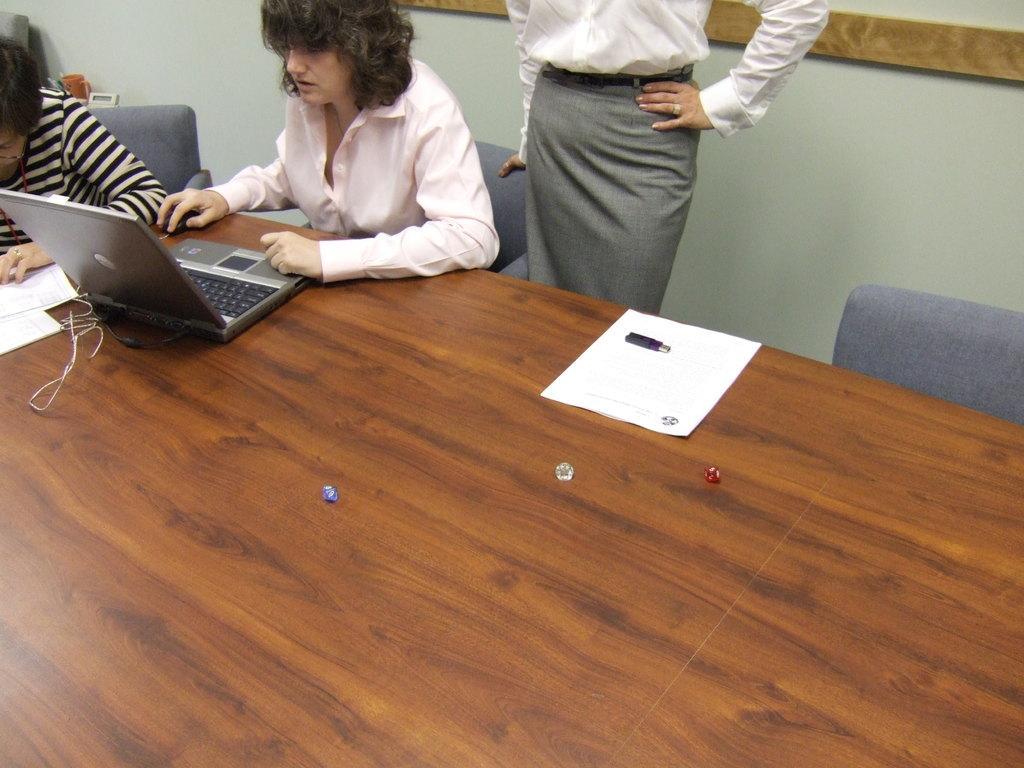Could you give a brief overview of what you see in this image? In this image I see 3 women, in which 2 of them are sitting and one of them is standing and there is a table in front and I see a laptop. In the background I see the wall. 